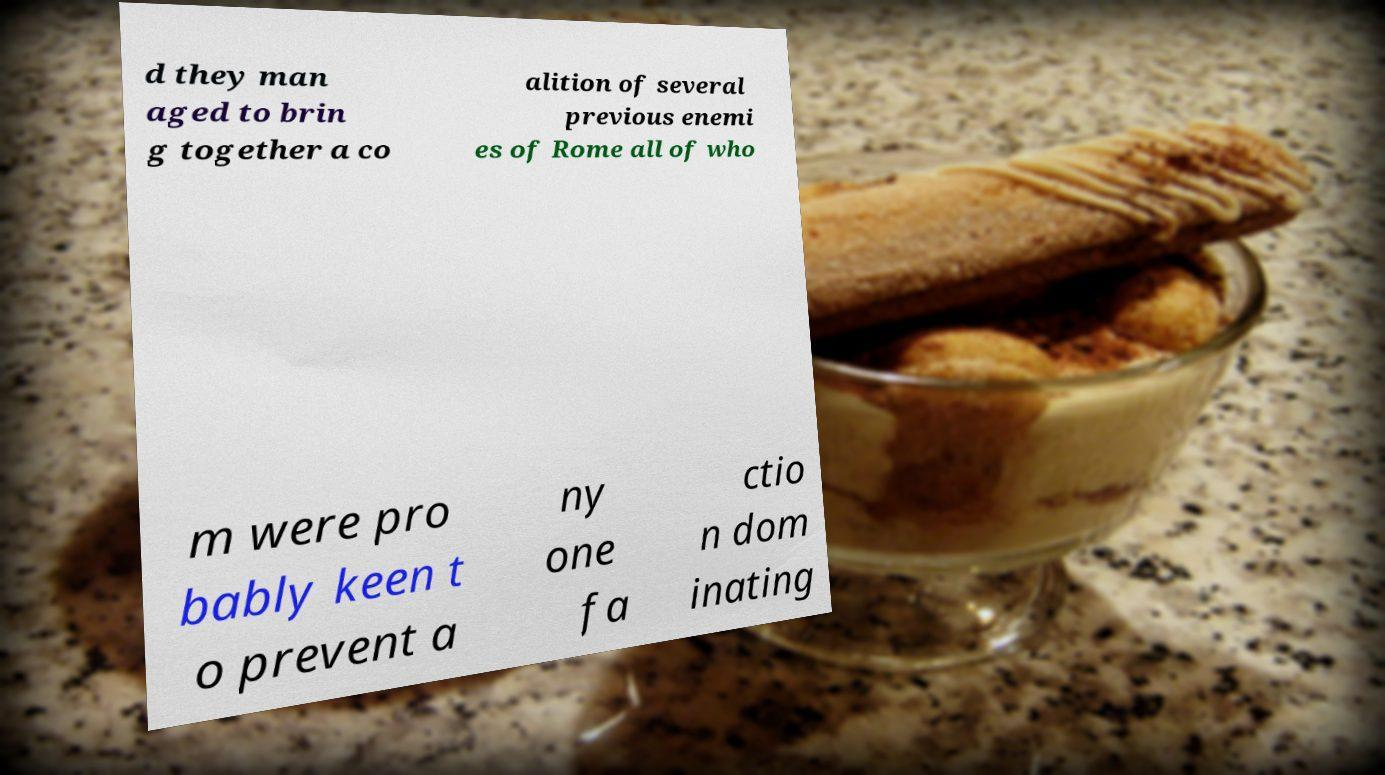There's text embedded in this image that I need extracted. Can you transcribe it verbatim? d they man aged to brin g together a co alition of several previous enemi es of Rome all of who m were pro bably keen t o prevent a ny one fa ctio n dom inating 